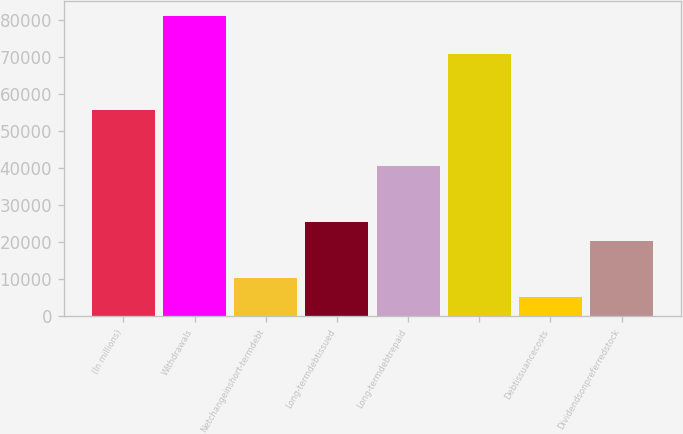<chart> <loc_0><loc_0><loc_500><loc_500><bar_chart><fcel>(In millions)<fcel>Withdrawals<fcel>Netchangeinshort-termdebt<fcel>Long-termdebtissued<fcel>Long-termdebtrepaid<fcel>Unnamed: 5<fcel>Debtissuancecosts<fcel>Dividendsonpreferredstock<nl><fcel>55630.2<fcel>80911.2<fcel>10124.4<fcel>25293<fcel>40461.6<fcel>70798.8<fcel>5068.2<fcel>20236.8<nl></chart> 